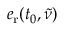<formula> <loc_0><loc_0><loc_500><loc_500>e _ { r } ( t _ { 0 } , \tilde { \nu } )</formula> 